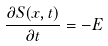<formula> <loc_0><loc_0><loc_500><loc_500>\frac { \partial S ( x , t ) } { \partial t } = - E</formula> 